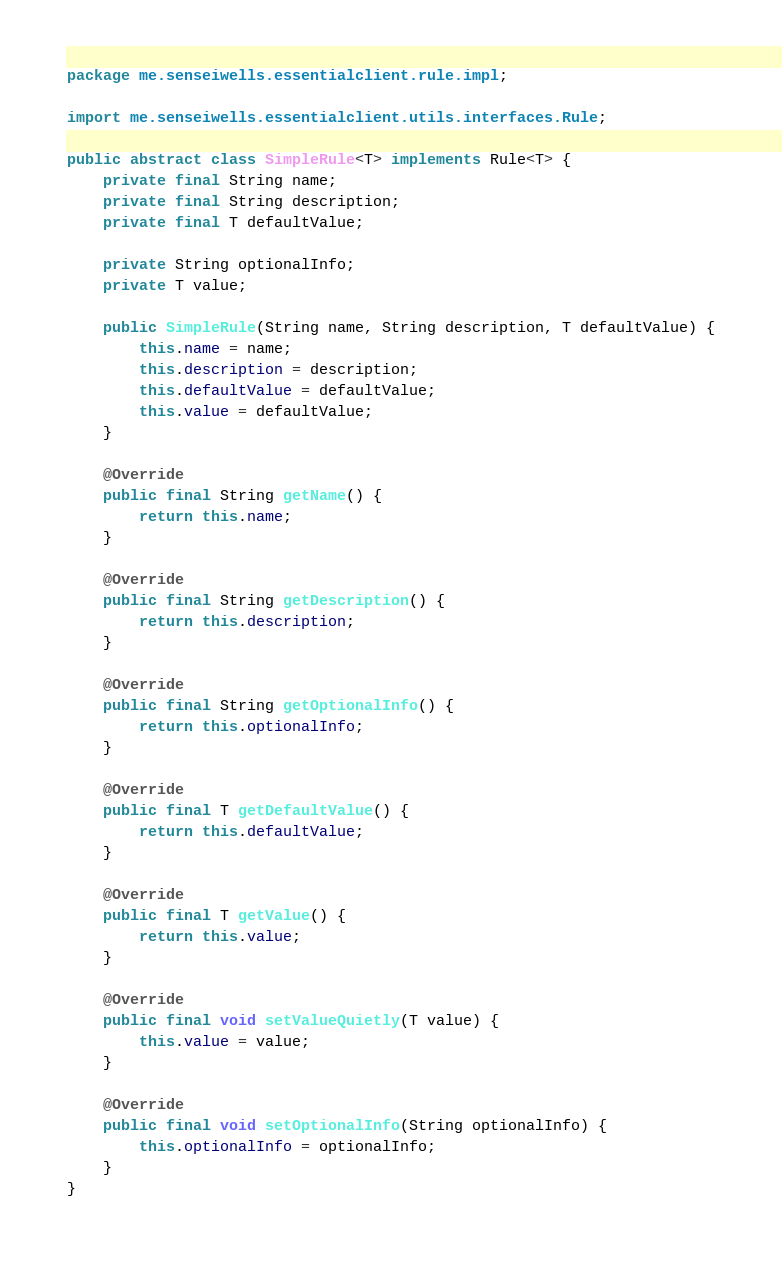<code> <loc_0><loc_0><loc_500><loc_500><_Java_>package me.senseiwells.essentialclient.rule.impl;

import me.senseiwells.essentialclient.utils.interfaces.Rule;

public abstract class SimpleRule<T> implements Rule<T> {
	private final String name;
	private final String description;
	private final T defaultValue;

	private String optionalInfo;
	private T value;

	public SimpleRule(String name, String description, T defaultValue) {
		this.name = name;
		this.description = description;
		this.defaultValue = defaultValue;
		this.value = defaultValue;
	}

	@Override
	public final String getName() {
		return this.name;
	}

	@Override
	public final String getDescription() {
		return this.description;
	}

	@Override
	public final String getOptionalInfo() {
		return this.optionalInfo;
	}

	@Override
	public final T getDefaultValue() {
		return this.defaultValue;
	}

	@Override
	public final T getValue() {
		return this.value;
	}

	@Override
	public final void setValueQuietly(T value) {
		this.value = value;
	}

	@Override
	public final void setOptionalInfo(String optionalInfo) {
		this.optionalInfo = optionalInfo;
	}
}
</code> 